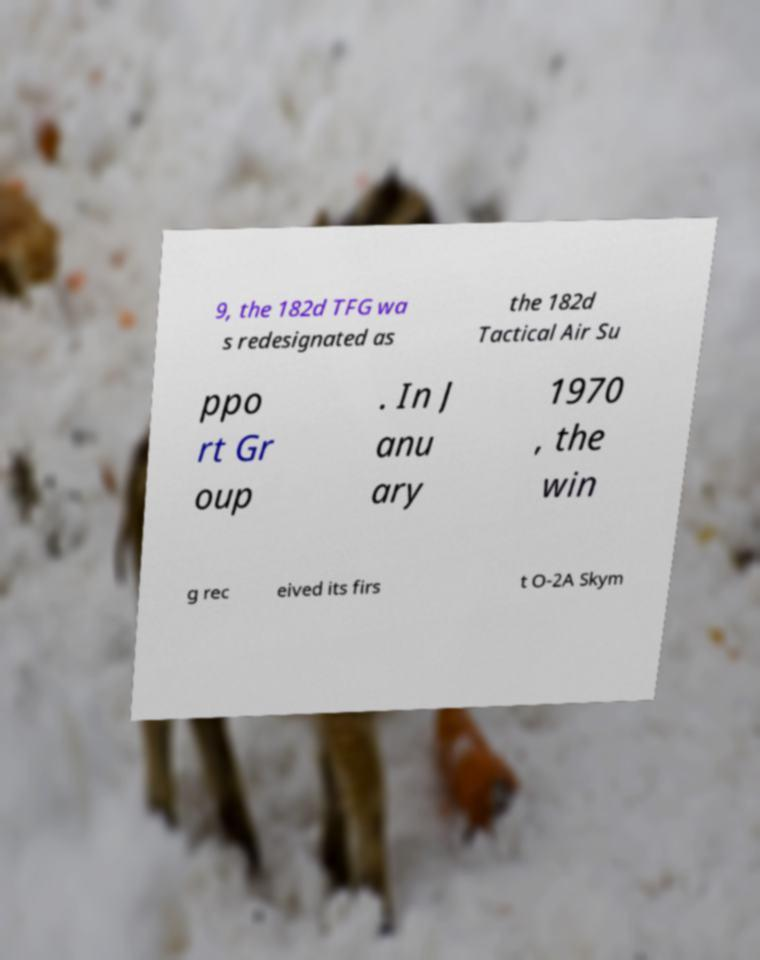For documentation purposes, I need the text within this image transcribed. Could you provide that? 9, the 182d TFG wa s redesignated as the 182d Tactical Air Su ppo rt Gr oup . In J anu ary 1970 , the win g rec eived its firs t O-2A Skym 